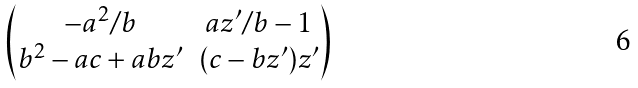Convert formula to latex. <formula><loc_0><loc_0><loc_500><loc_500>\begin{pmatrix} - a ^ { 2 } / b & a z ^ { \prime } / b - 1 \\ b ^ { 2 } - a c + a b z ^ { \prime } & ( c - b z ^ { \prime } ) z ^ { \prime } \end{pmatrix}</formula> 